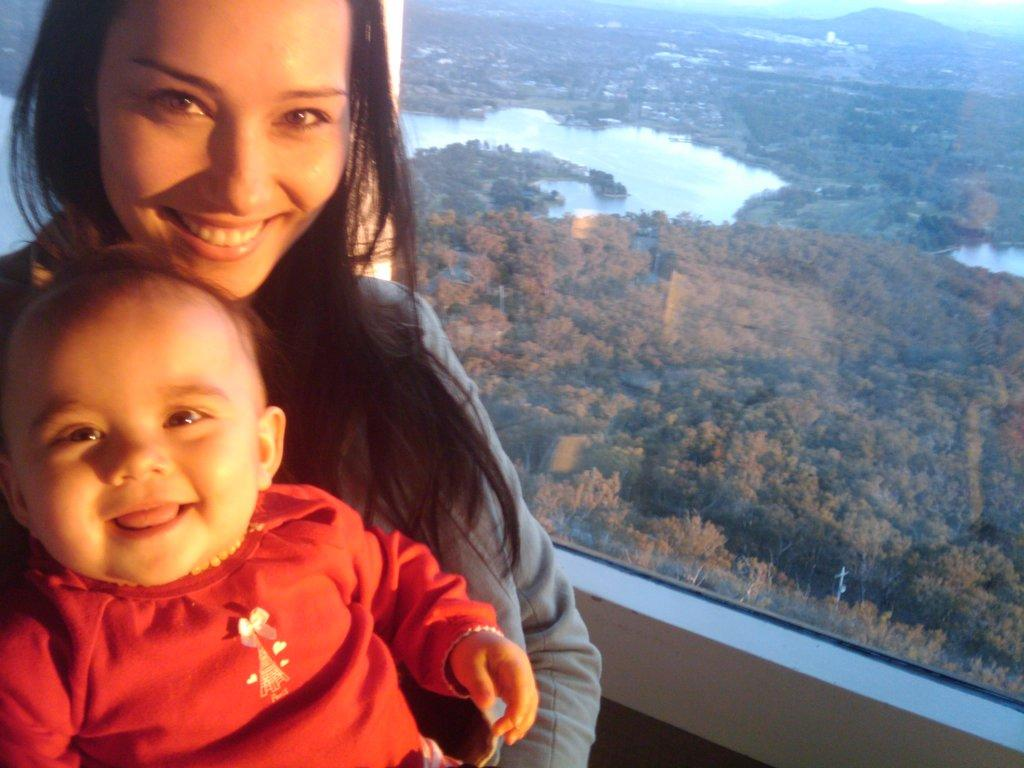Who is present in the image? There is a lady in the image. What is the lady doing in the image? The lady is smiling. Is there anyone else with the lady in the image? Yes, there is a baby with the lady. What can be seen through the glass door in the image? Many trees and water are visible behind the glass door. What degree does the lady hold in the image? There is no information about the lady's degree in the image. Can you see a tank in the image? No, there is no tank visible in the image. 